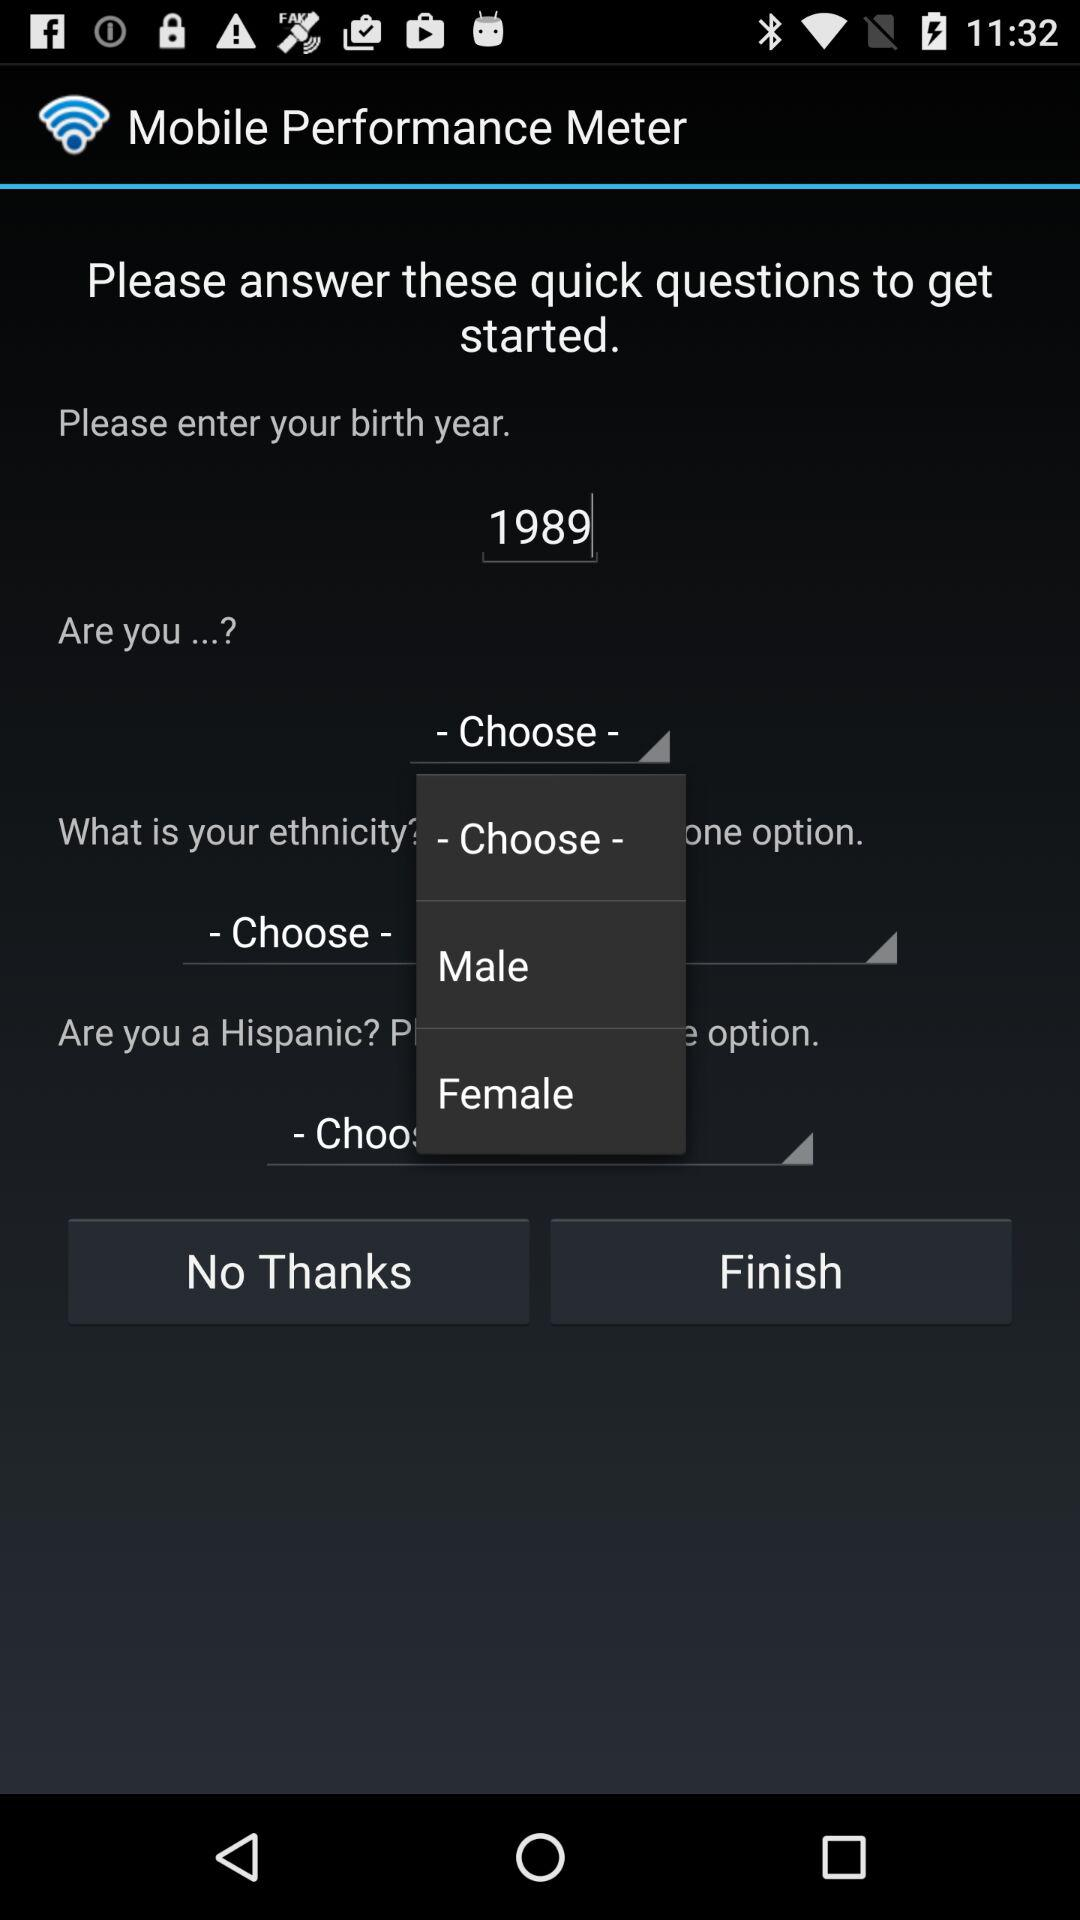What is the application name? The application name is "Mobile Performance Meter". 